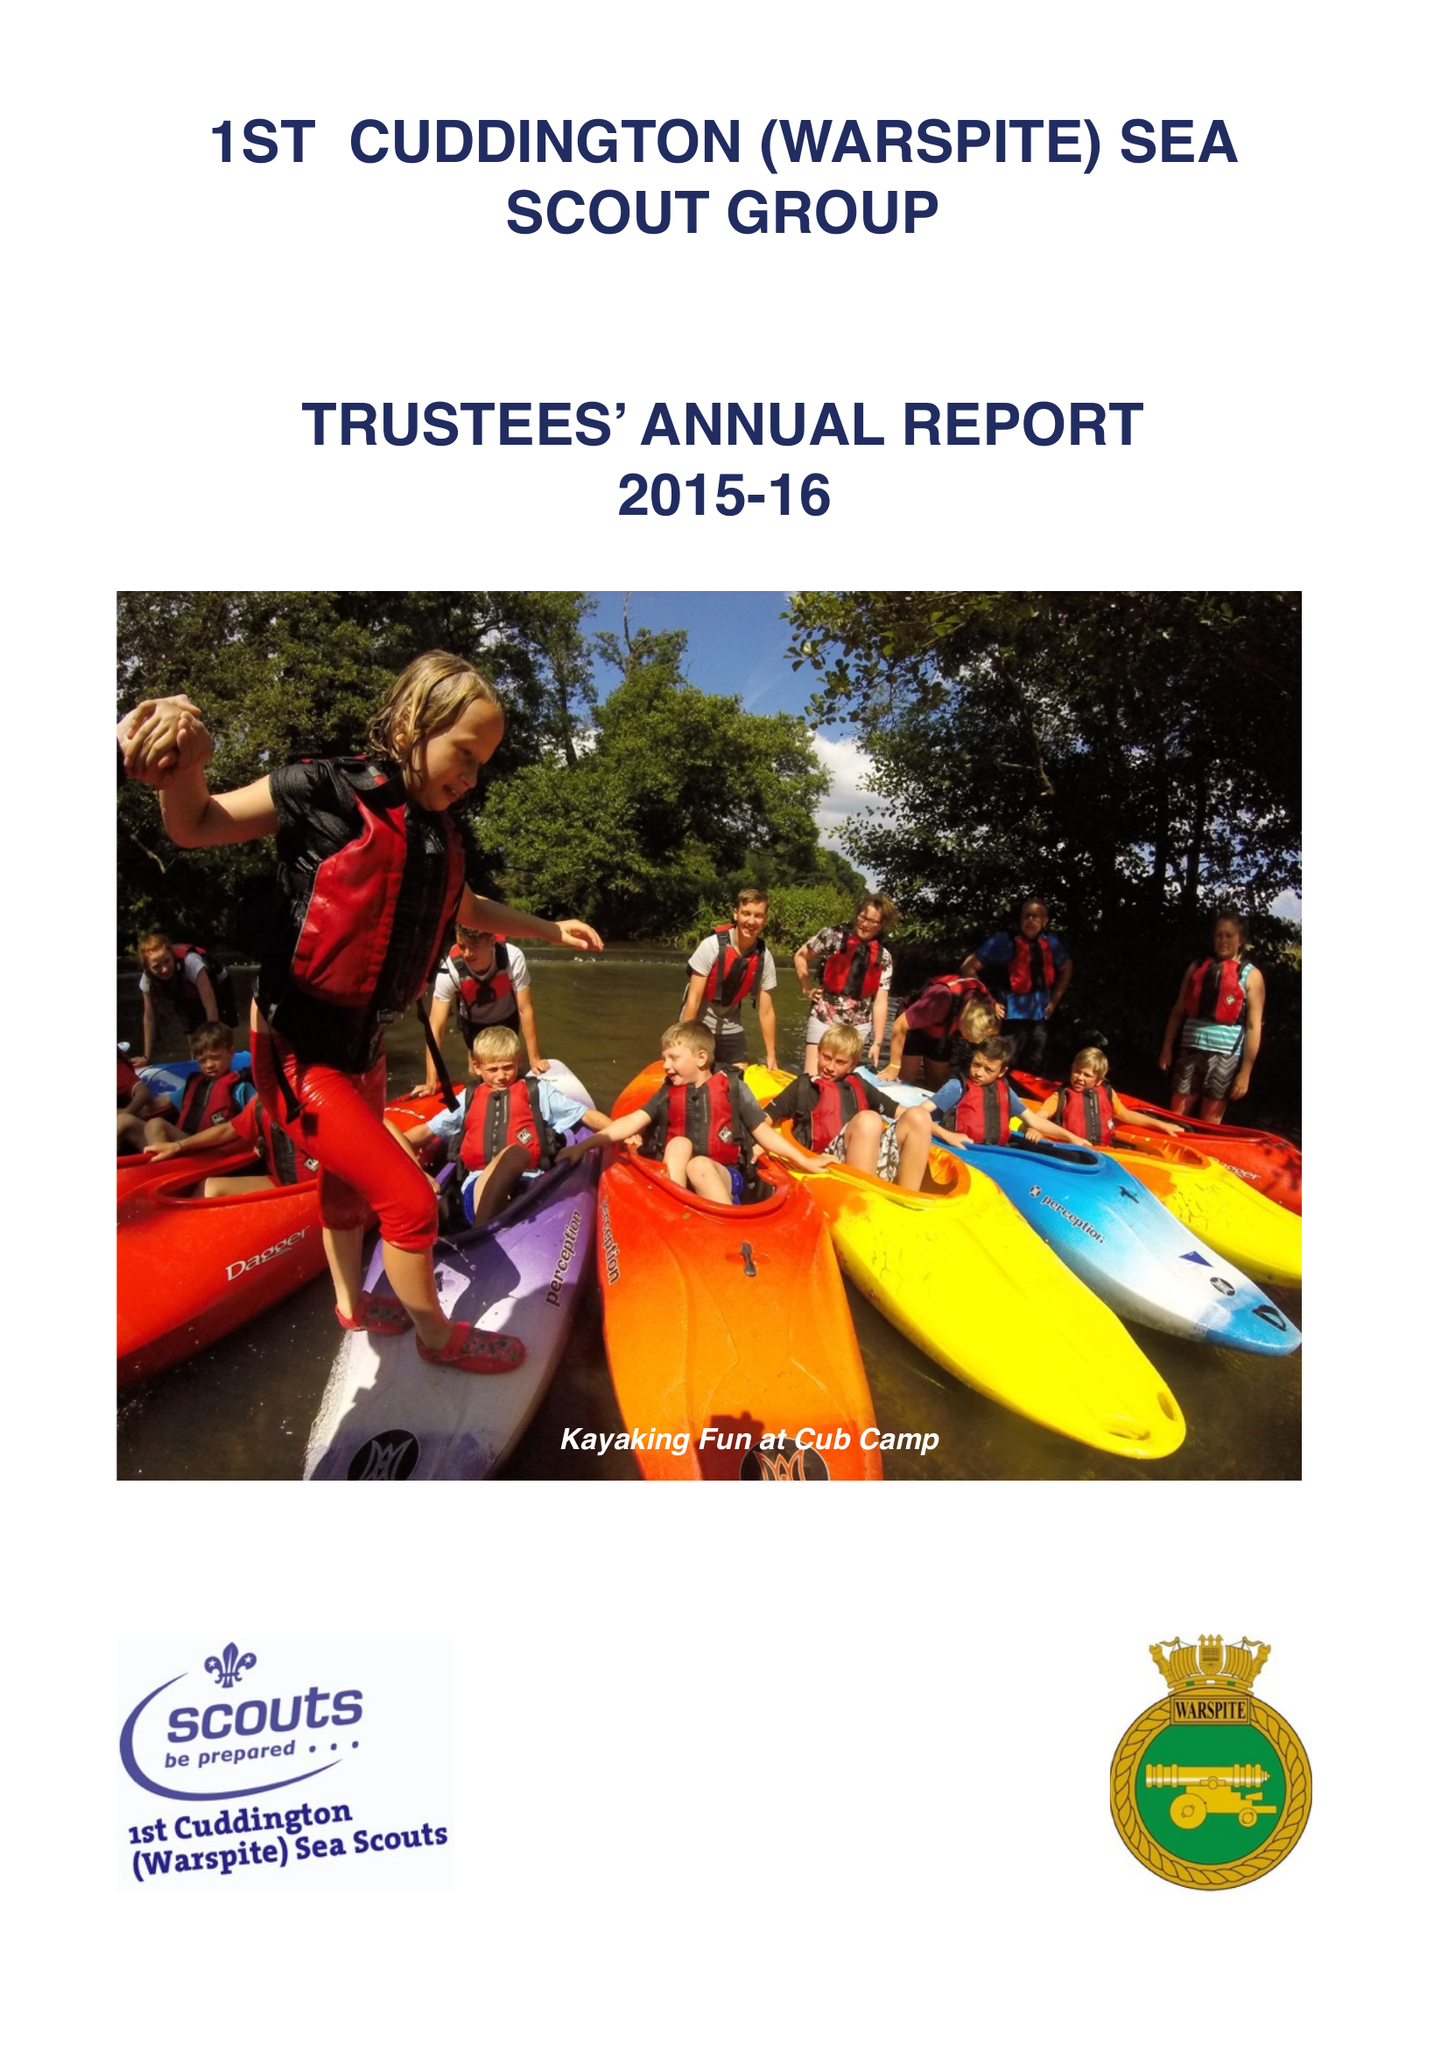What is the value for the charity_number?
Answer the question using a single word or phrase. 305711 